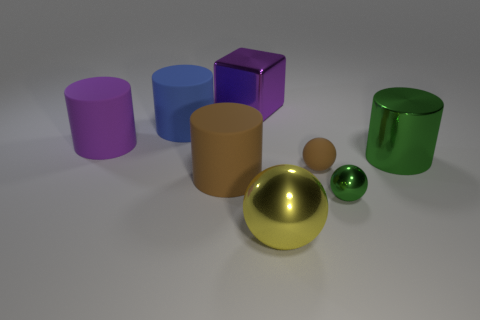Could you describe the lighting in the scene? The lighting appears soft and diffused, with no harsh shadows. It's consistent with ambient lighting found in studio settings, highlighting the objects from above and slightly in front. 